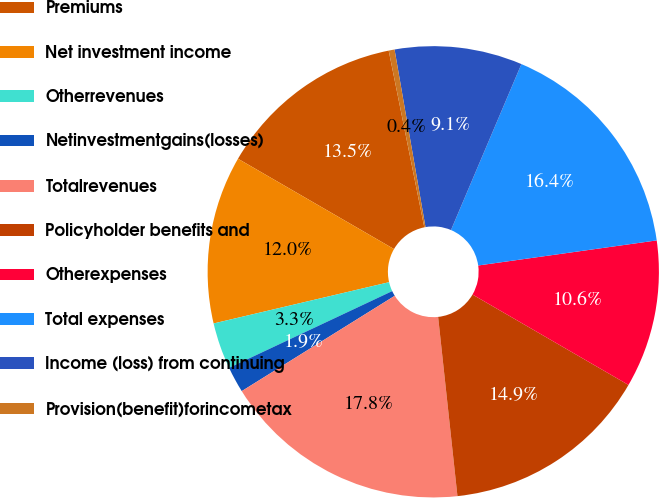Convert chart to OTSL. <chart><loc_0><loc_0><loc_500><loc_500><pie_chart><fcel>Premiums<fcel>Net investment income<fcel>Otherrevenues<fcel>Netinvestmentgains(losses)<fcel>Totalrevenues<fcel>Policyholder benefits and<fcel>Otherexpenses<fcel>Total expenses<fcel>Income (loss) from continuing<fcel>Provision(benefit)forincometax<nl><fcel>13.48%<fcel>12.03%<fcel>3.32%<fcel>1.87%<fcel>17.84%<fcel>14.93%<fcel>10.58%<fcel>16.39%<fcel>9.13%<fcel>0.42%<nl></chart> 